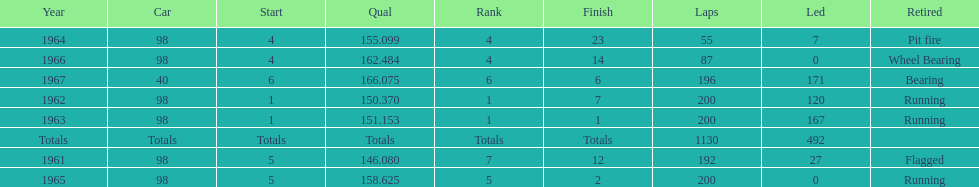In how many indy 500 races, has jones been flagged? 1. 